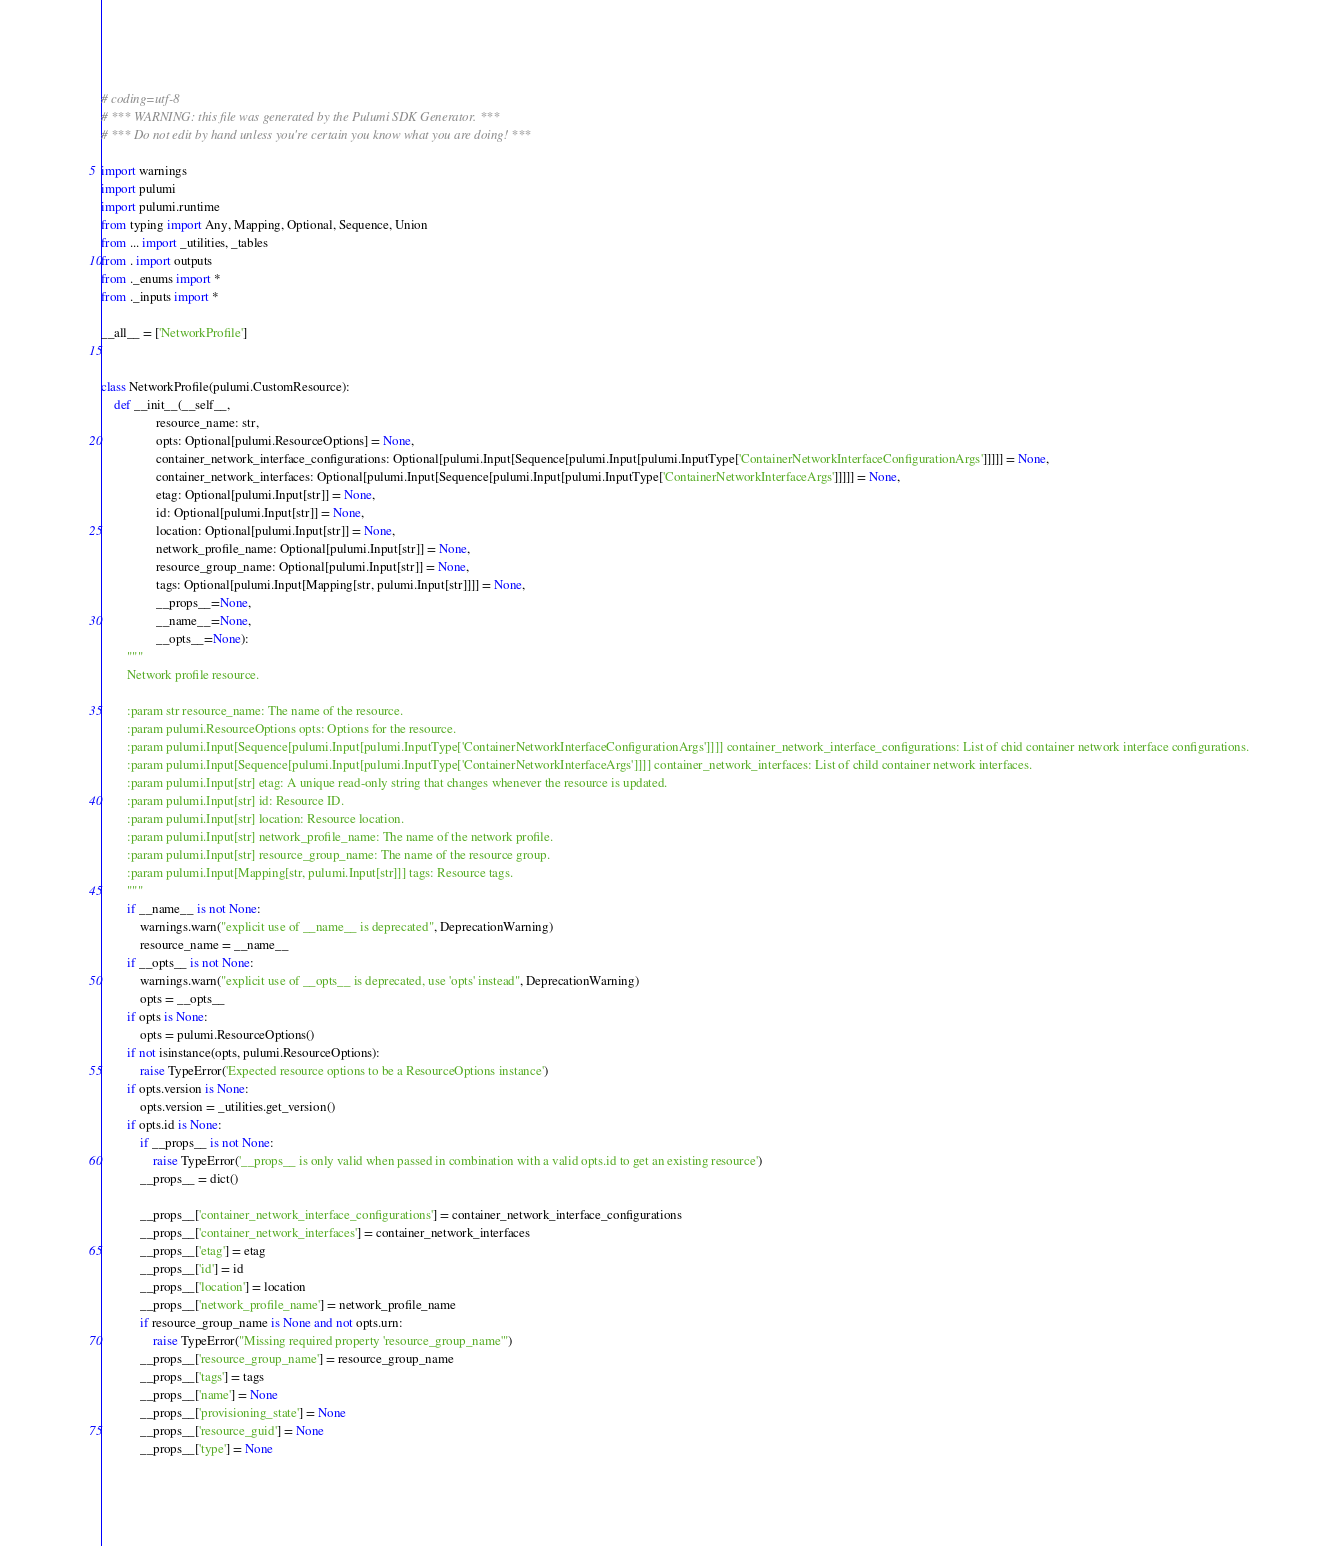<code> <loc_0><loc_0><loc_500><loc_500><_Python_># coding=utf-8
# *** WARNING: this file was generated by the Pulumi SDK Generator. ***
# *** Do not edit by hand unless you're certain you know what you are doing! ***

import warnings
import pulumi
import pulumi.runtime
from typing import Any, Mapping, Optional, Sequence, Union
from ... import _utilities, _tables
from . import outputs
from ._enums import *
from ._inputs import *

__all__ = ['NetworkProfile']


class NetworkProfile(pulumi.CustomResource):
    def __init__(__self__,
                 resource_name: str,
                 opts: Optional[pulumi.ResourceOptions] = None,
                 container_network_interface_configurations: Optional[pulumi.Input[Sequence[pulumi.Input[pulumi.InputType['ContainerNetworkInterfaceConfigurationArgs']]]]] = None,
                 container_network_interfaces: Optional[pulumi.Input[Sequence[pulumi.Input[pulumi.InputType['ContainerNetworkInterfaceArgs']]]]] = None,
                 etag: Optional[pulumi.Input[str]] = None,
                 id: Optional[pulumi.Input[str]] = None,
                 location: Optional[pulumi.Input[str]] = None,
                 network_profile_name: Optional[pulumi.Input[str]] = None,
                 resource_group_name: Optional[pulumi.Input[str]] = None,
                 tags: Optional[pulumi.Input[Mapping[str, pulumi.Input[str]]]] = None,
                 __props__=None,
                 __name__=None,
                 __opts__=None):
        """
        Network profile resource.

        :param str resource_name: The name of the resource.
        :param pulumi.ResourceOptions opts: Options for the resource.
        :param pulumi.Input[Sequence[pulumi.Input[pulumi.InputType['ContainerNetworkInterfaceConfigurationArgs']]]] container_network_interface_configurations: List of chid container network interface configurations.
        :param pulumi.Input[Sequence[pulumi.Input[pulumi.InputType['ContainerNetworkInterfaceArgs']]]] container_network_interfaces: List of child container network interfaces.
        :param pulumi.Input[str] etag: A unique read-only string that changes whenever the resource is updated.
        :param pulumi.Input[str] id: Resource ID.
        :param pulumi.Input[str] location: Resource location.
        :param pulumi.Input[str] network_profile_name: The name of the network profile.
        :param pulumi.Input[str] resource_group_name: The name of the resource group.
        :param pulumi.Input[Mapping[str, pulumi.Input[str]]] tags: Resource tags.
        """
        if __name__ is not None:
            warnings.warn("explicit use of __name__ is deprecated", DeprecationWarning)
            resource_name = __name__
        if __opts__ is not None:
            warnings.warn("explicit use of __opts__ is deprecated, use 'opts' instead", DeprecationWarning)
            opts = __opts__
        if opts is None:
            opts = pulumi.ResourceOptions()
        if not isinstance(opts, pulumi.ResourceOptions):
            raise TypeError('Expected resource options to be a ResourceOptions instance')
        if opts.version is None:
            opts.version = _utilities.get_version()
        if opts.id is None:
            if __props__ is not None:
                raise TypeError('__props__ is only valid when passed in combination with a valid opts.id to get an existing resource')
            __props__ = dict()

            __props__['container_network_interface_configurations'] = container_network_interface_configurations
            __props__['container_network_interfaces'] = container_network_interfaces
            __props__['etag'] = etag
            __props__['id'] = id
            __props__['location'] = location
            __props__['network_profile_name'] = network_profile_name
            if resource_group_name is None and not opts.urn:
                raise TypeError("Missing required property 'resource_group_name'")
            __props__['resource_group_name'] = resource_group_name
            __props__['tags'] = tags
            __props__['name'] = None
            __props__['provisioning_state'] = None
            __props__['resource_guid'] = None
            __props__['type'] = None</code> 